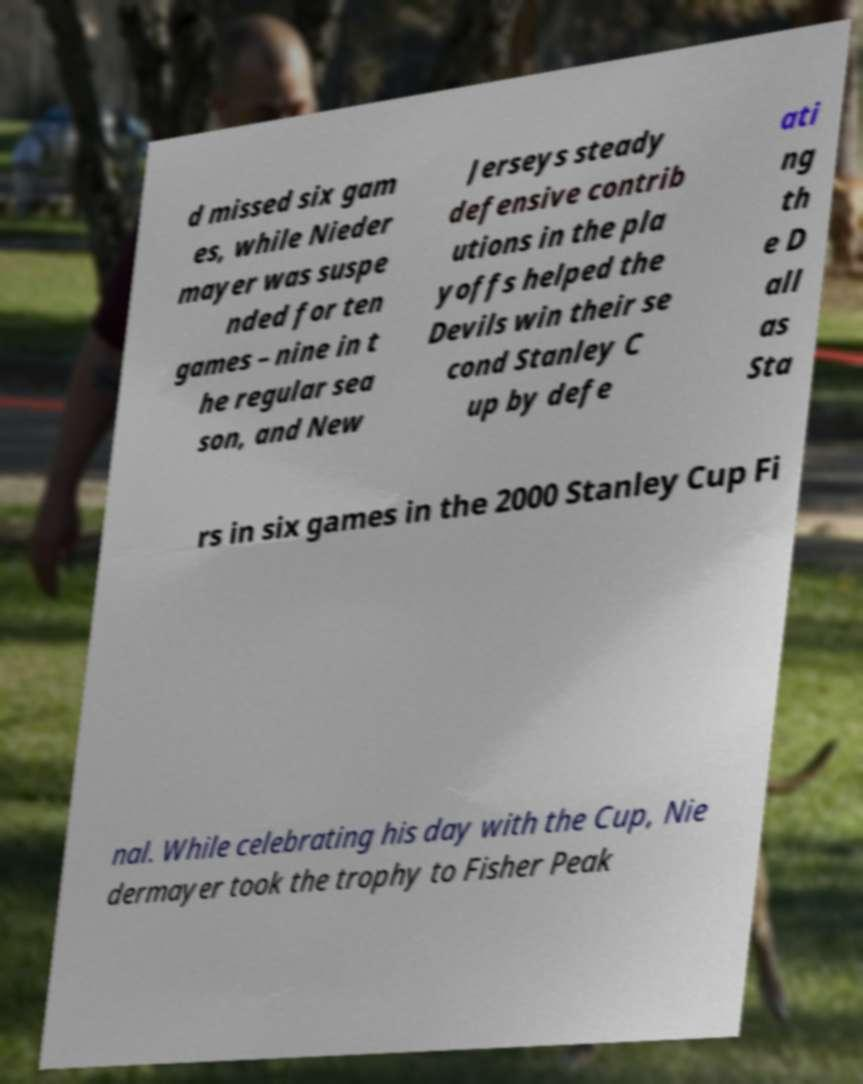Can you accurately transcribe the text from the provided image for me? d missed six gam es, while Nieder mayer was suspe nded for ten games – nine in t he regular sea son, and New Jerseys steady defensive contrib utions in the pla yoffs helped the Devils win their se cond Stanley C up by defe ati ng th e D all as Sta rs in six games in the 2000 Stanley Cup Fi nal. While celebrating his day with the Cup, Nie dermayer took the trophy to Fisher Peak 